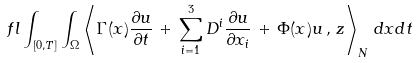<formula> <loc_0><loc_0><loc_500><loc_500>\ f l \int _ { [ 0 , T ] } \int _ { \Omega } \left \langle \Gamma ( x ) \frac { \partial u } { \partial t } \, + \, \sum _ { i = 1 } ^ { 3 } D ^ { i } \frac { \partial u } { \partial x _ { i } } \, + \, \Phi ( x ) u \, , \, z \right \rangle _ { N } \, d x d t</formula> 